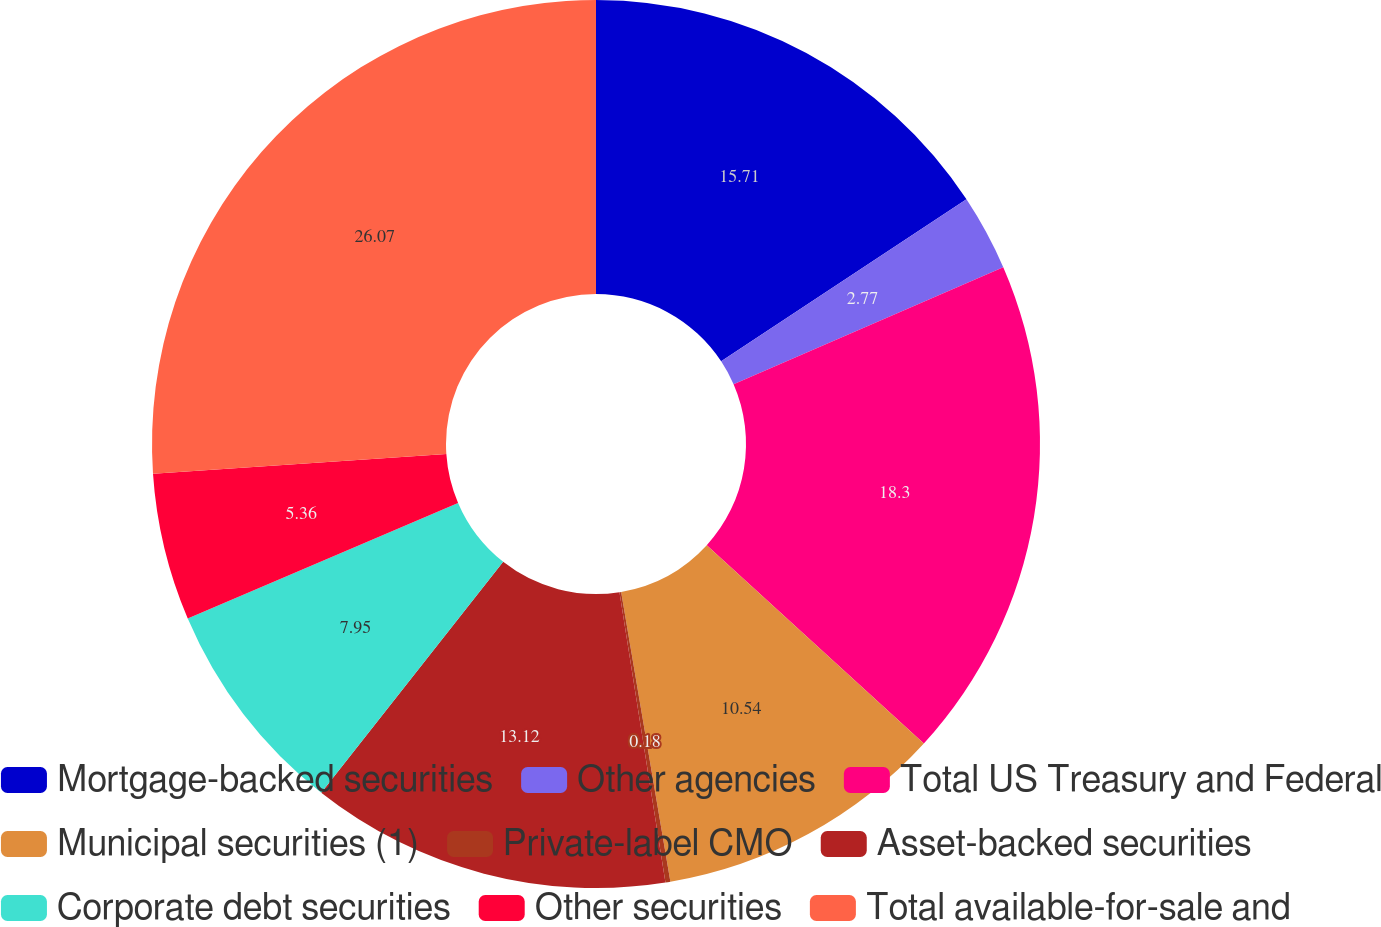Convert chart to OTSL. <chart><loc_0><loc_0><loc_500><loc_500><pie_chart><fcel>Mortgage-backed securities<fcel>Other agencies<fcel>Total US Treasury and Federal<fcel>Municipal securities (1)<fcel>Private-label CMO<fcel>Asset-backed securities<fcel>Corporate debt securities<fcel>Other securities<fcel>Total available-for-sale and<nl><fcel>15.71%<fcel>2.77%<fcel>18.3%<fcel>10.54%<fcel>0.18%<fcel>13.12%<fcel>7.95%<fcel>5.36%<fcel>26.07%<nl></chart> 